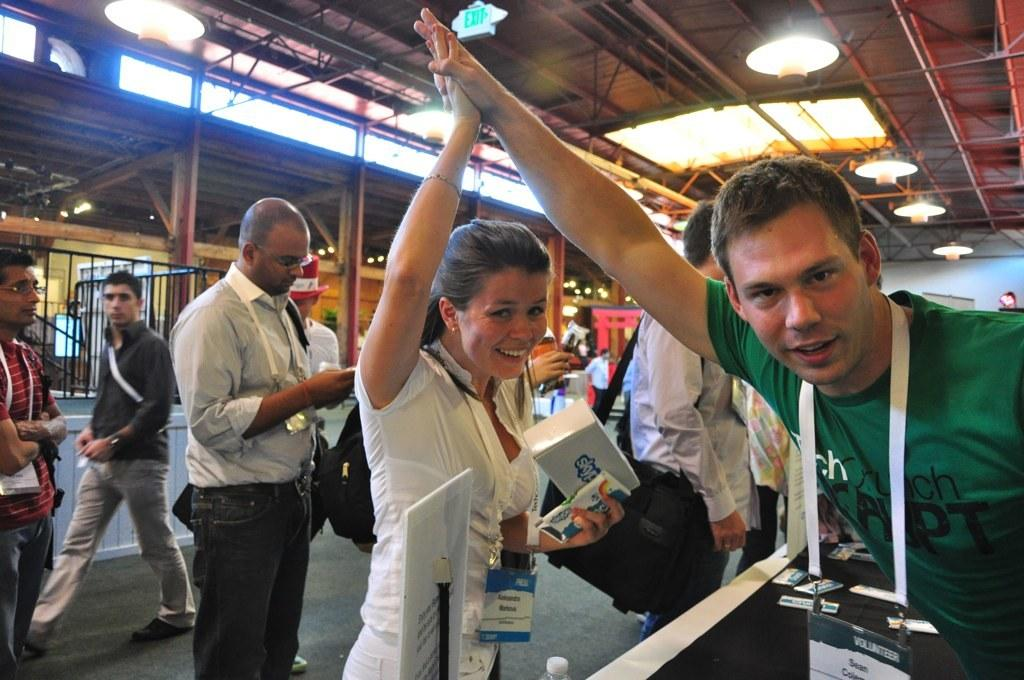How many people are in the image? There are people in the image, but the exact number is not specified. What is the lady doing in the image? A lady is standing in the image. What is someone holding in the image? Someone is holding a carton in the image. What can be seen in the background of the image? In the background of the image, there are grills, lights, and walls. What type of pin can be seen attached to the lady's clothing in the image? There is no pin visible on the lady's clothing in the image. What sound do the bells make in the image? There are no bells present in the image. 